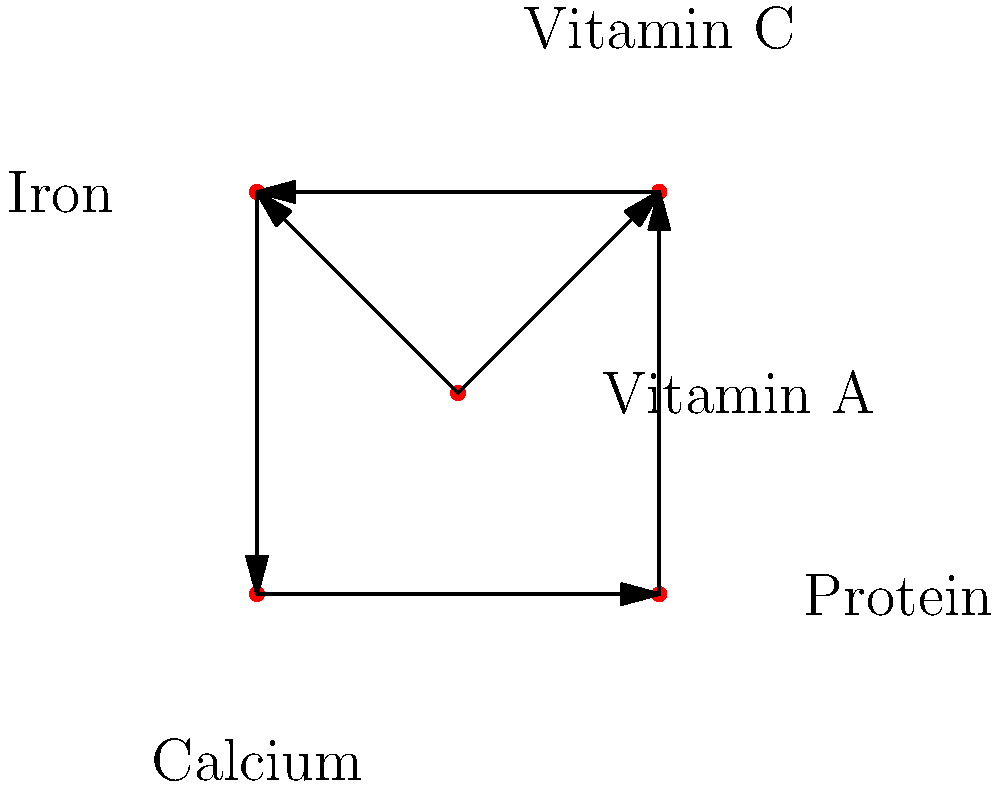In the nutrient network diagram above, which nutrient has the highest out-degree (number of outgoing connections) and what does this imply about its role in a baby's diet with allergies? To answer this question, we need to follow these steps:

1. Understand the concept of out-degree in a directed graph:
   The out-degree of a vertex is the number of edges pointing away from it.

2. Analyze the diagram:
   - Vitamin A: 2 outgoing edges (to Vitamin C and Iron)
   - Vitamin C: 1 outgoing edge (to Iron)
   - Iron: 1 outgoing edge (to Calcium)
   - Calcium: 1 outgoing edge (to Protein)
   - Protein: 1 outgoing edge (to Vitamin C)

3. Identify the nutrient with the highest out-degree:
   Vitamin A has the highest out-degree with 2 outgoing connections.

4. Interpret the implications:
   - A high out-degree suggests that Vitamin A influences or interacts with multiple other nutrients.
   - In a baby's diet with allergies, this implies that Vitamin A plays a central role in nutrient interactions.
   - Ensuring adequate Vitamin A intake may help support the absorption or utilization of other nutrients, which is crucial when dealing with dietary restrictions due to allergies.
   - Vitamin A is also important for immune function and growth, which are particularly relevant for babies with allergies.

5. Consider the holistic perspective:
   While Vitamin A appears central in this network, a balanced approach considering all nutrients is still necessary, especially when accommodating allergies in a baby's diet plan.
Answer: Vitamin A; central role in nutrient interactions, supporting absorption of other nutrients despite dietary restrictions. 